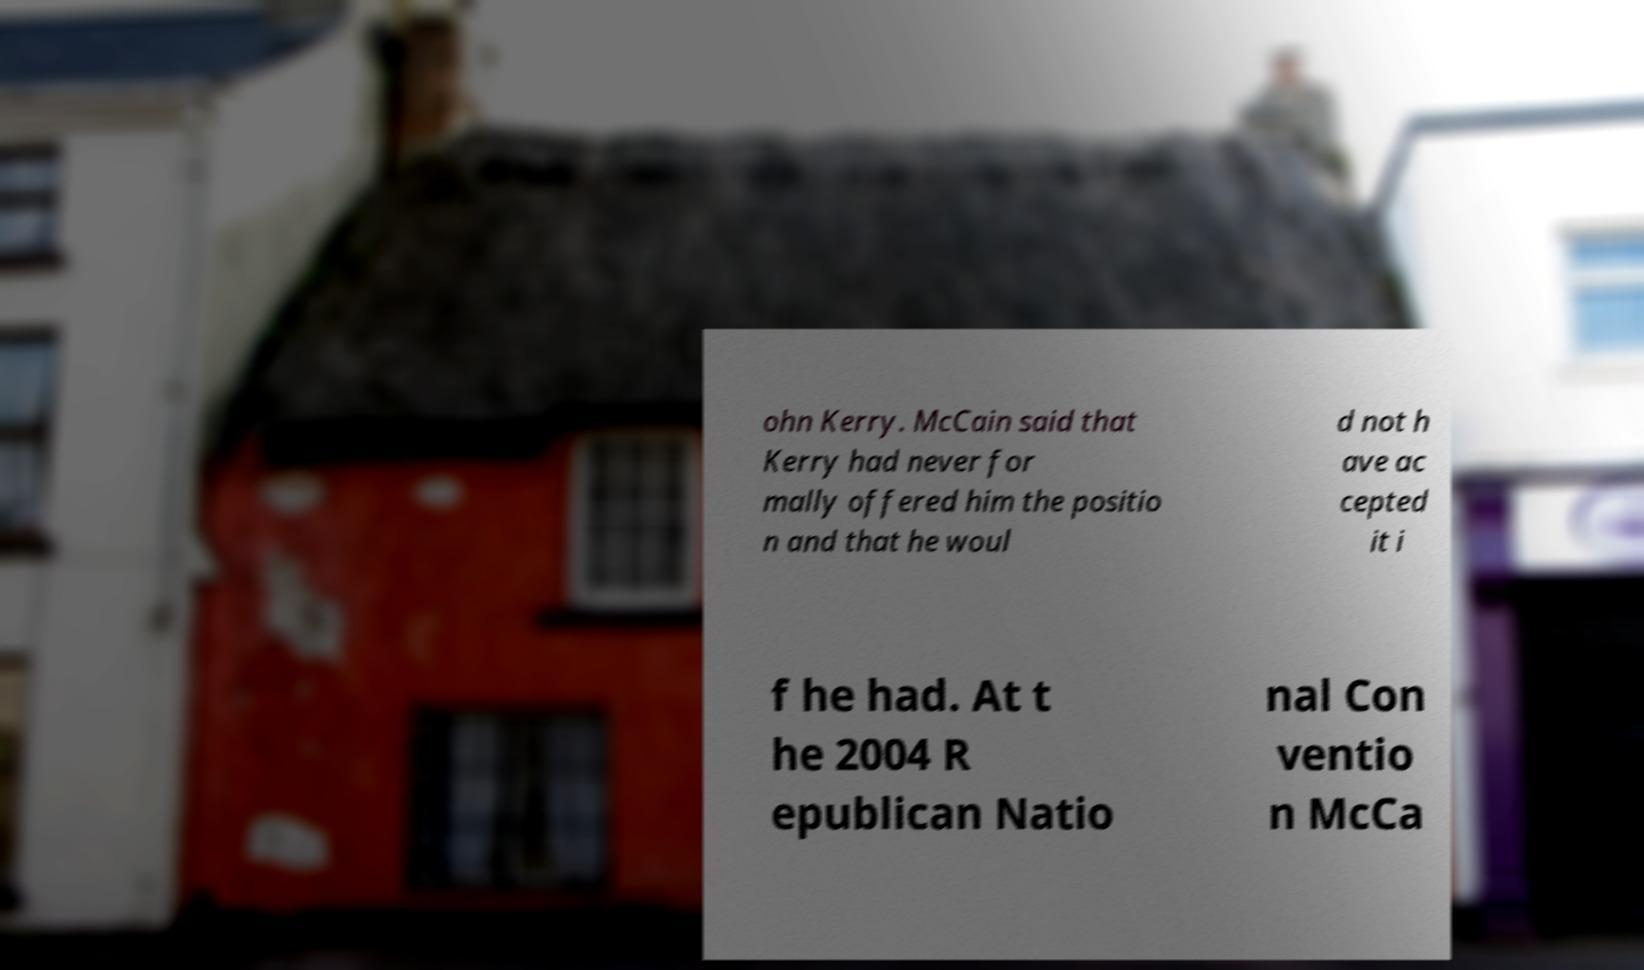I need the written content from this picture converted into text. Can you do that? ohn Kerry. McCain said that Kerry had never for mally offered him the positio n and that he woul d not h ave ac cepted it i f he had. At t he 2004 R epublican Natio nal Con ventio n McCa 